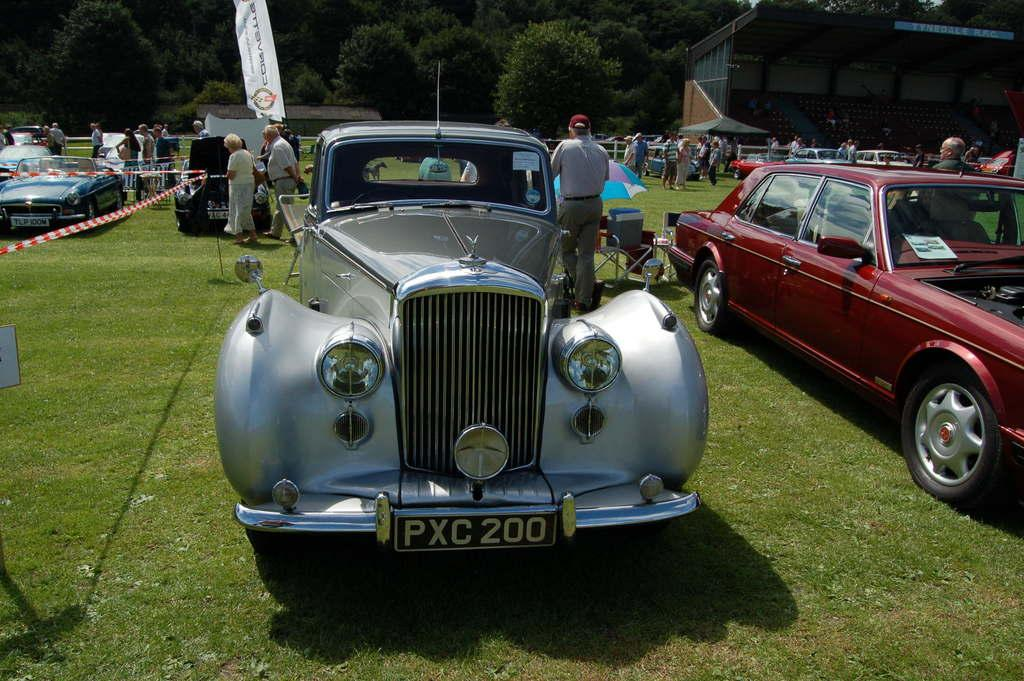What type of vehicles are on the ground in the image? There are cars on the ground in the image. What can be seen in the background of the image? There are people standing, fencing, trees, and a building in the background of the image. How many mice are sitting on the calendar in the image? There are no mice or calendar present in the image. What type of pickle is being used as a prop in the image? There is no pickle present in the image. 